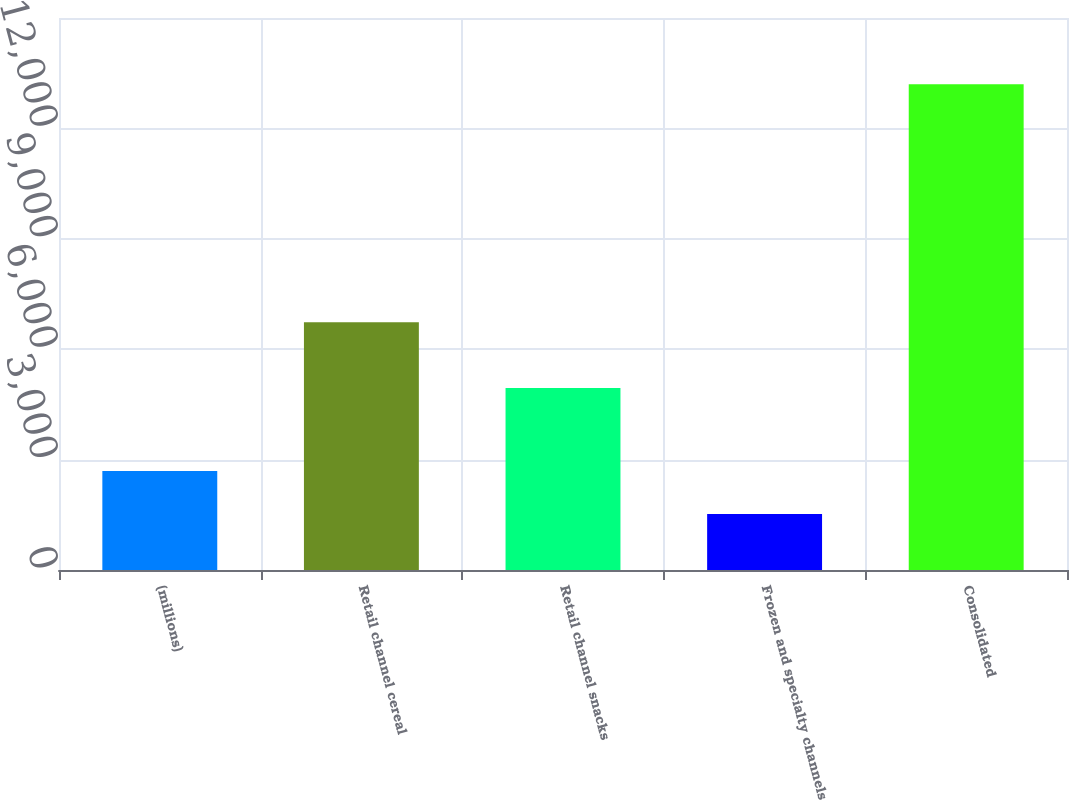Convert chart. <chart><loc_0><loc_0><loc_500><loc_500><bar_chart><fcel>(millions)<fcel>Retail channel cereal<fcel>Retail channel snacks<fcel>Frozen and specialty channels<fcel>Consolidated<nl><fcel>2686.9<fcel>6730<fcel>4949<fcel>1519<fcel>13198<nl></chart> 